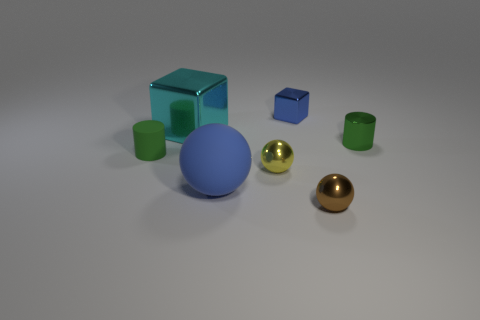The metallic cylinder is what size?
Offer a very short reply. Small. How many other things are the same color as the small metal block?
Your answer should be compact. 1. There is a tiny thing in front of the large rubber ball; is its shape the same as the large matte object?
Your answer should be compact. Yes. There is a big rubber object that is the same shape as the brown shiny object; what is its color?
Offer a terse response. Blue. Is there anything else that is made of the same material as the small blue block?
Your answer should be very brief. Yes. The other shiny thing that is the same shape as the brown metallic thing is what size?
Make the answer very short. Small. What material is the ball that is in front of the small yellow shiny thing and right of the big blue rubber ball?
Provide a succinct answer. Metal. Do the metal cube that is left of the small yellow object and the tiny shiny block have the same color?
Your response must be concise. No. Is the color of the tiny metal block the same as the small cylinder that is on the left side of the large metallic object?
Give a very brief answer. No. There is a small rubber thing; are there any things on the right side of it?
Give a very brief answer. Yes. 